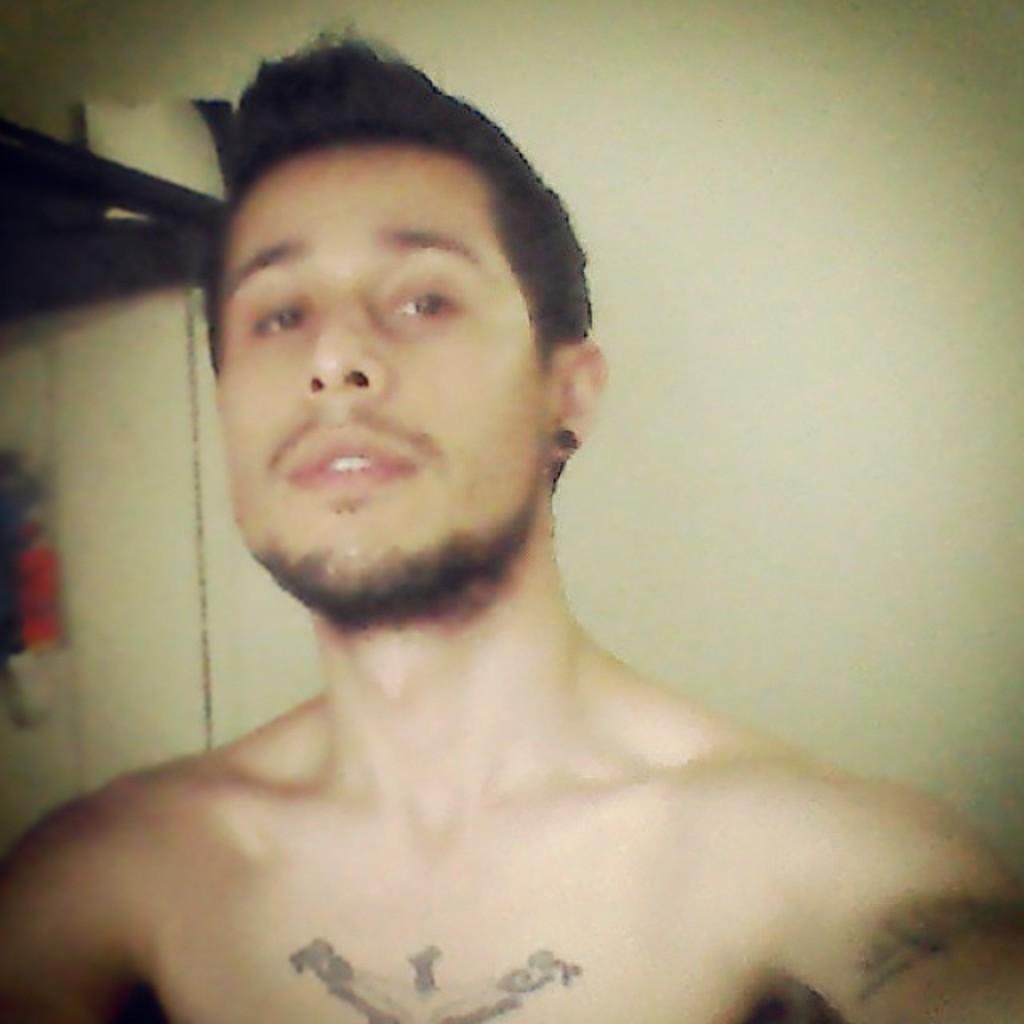Please provide a concise description of this image. This is the picture of a person who has some tattoo on his body and to the side there is a something. 